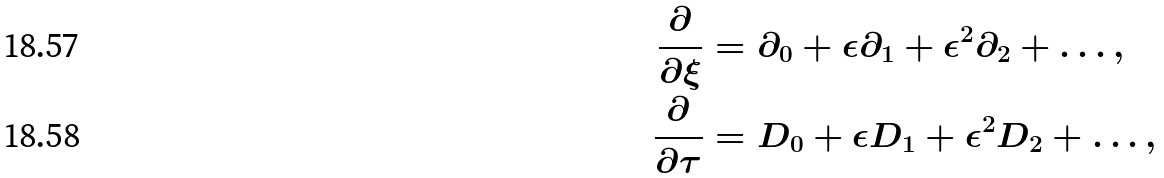Convert formula to latex. <formula><loc_0><loc_0><loc_500><loc_500>\frac { \partial } { \partial \xi } & = \partial _ { 0 } + \epsilon \partial _ { 1 } + \epsilon ^ { 2 } \partial _ { 2 } + \dots , \\ \frac { \partial } { \partial \tau } & = D _ { 0 } + \epsilon D _ { 1 } + \epsilon ^ { 2 } D _ { 2 } + \dots ,</formula> 